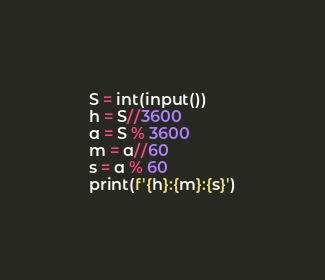<code> <loc_0><loc_0><loc_500><loc_500><_Python_>S = int(input())
h = S//3600
a = S % 3600
m = a//60
s = a % 60
print(f'{h}:{m}:{s}')

</code> 